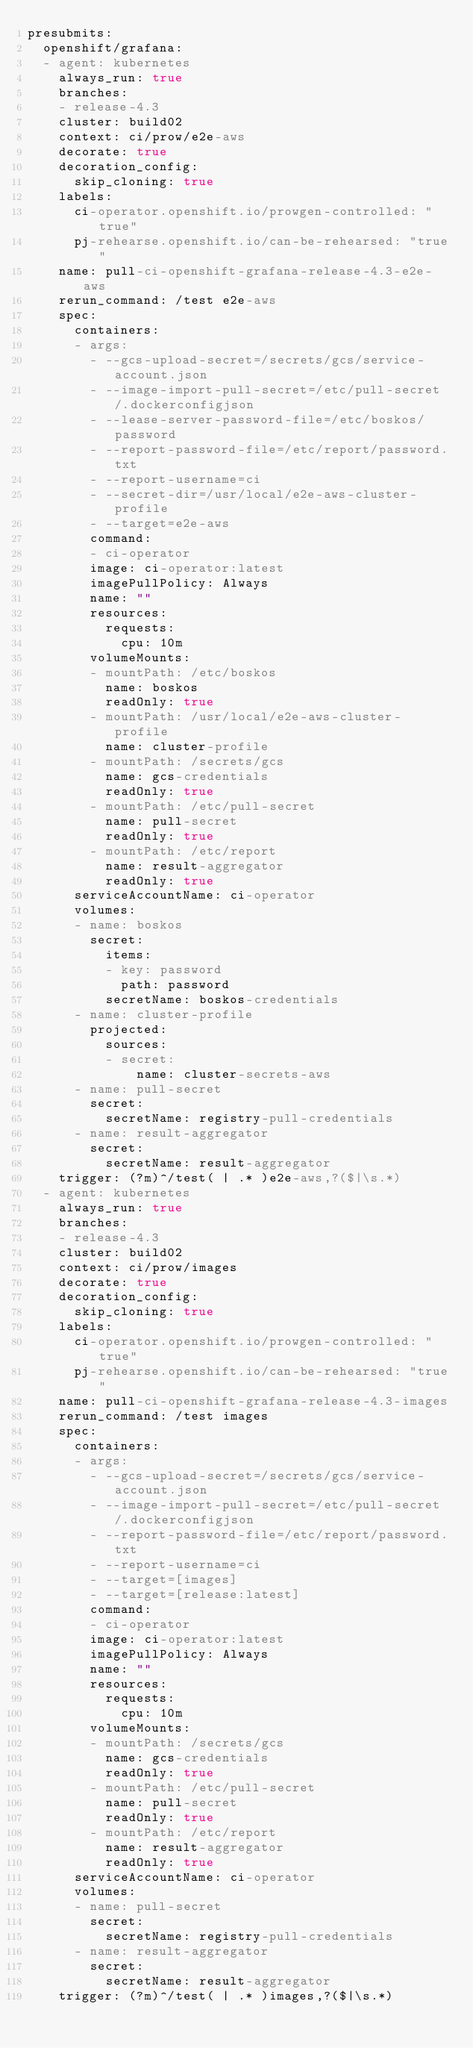<code> <loc_0><loc_0><loc_500><loc_500><_YAML_>presubmits:
  openshift/grafana:
  - agent: kubernetes
    always_run: true
    branches:
    - release-4.3
    cluster: build02
    context: ci/prow/e2e-aws
    decorate: true
    decoration_config:
      skip_cloning: true
    labels:
      ci-operator.openshift.io/prowgen-controlled: "true"
      pj-rehearse.openshift.io/can-be-rehearsed: "true"
    name: pull-ci-openshift-grafana-release-4.3-e2e-aws
    rerun_command: /test e2e-aws
    spec:
      containers:
      - args:
        - --gcs-upload-secret=/secrets/gcs/service-account.json
        - --image-import-pull-secret=/etc/pull-secret/.dockerconfigjson
        - --lease-server-password-file=/etc/boskos/password
        - --report-password-file=/etc/report/password.txt
        - --report-username=ci
        - --secret-dir=/usr/local/e2e-aws-cluster-profile
        - --target=e2e-aws
        command:
        - ci-operator
        image: ci-operator:latest
        imagePullPolicy: Always
        name: ""
        resources:
          requests:
            cpu: 10m
        volumeMounts:
        - mountPath: /etc/boskos
          name: boskos
          readOnly: true
        - mountPath: /usr/local/e2e-aws-cluster-profile
          name: cluster-profile
        - mountPath: /secrets/gcs
          name: gcs-credentials
          readOnly: true
        - mountPath: /etc/pull-secret
          name: pull-secret
          readOnly: true
        - mountPath: /etc/report
          name: result-aggregator
          readOnly: true
      serviceAccountName: ci-operator
      volumes:
      - name: boskos
        secret:
          items:
          - key: password
            path: password
          secretName: boskos-credentials
      - name: cluster-profile
        projected:
          sources:
          - secret:
              name: cluster-secrets-aws
      - name: pull-secret
        secret:
          secretName: registry-pull-credentials
      - name: result-aggregator
        secret:
          secretName: result-aggregator
    trigger: (?m)^/test( | .* )e2e-aws,?($|\s.*)
  - agent: kubernetes
    always_run: true
    branches:
    - release-4.3
    cluster: build02
    context: ci/prow/images
    decorate: true
    decoration_config:
      skip_cloning: true
    labels:
      ci-operator.openshift.io/prowgen-controlled: "true"
      pj-rehearse.openshift.io/can-be-rehearsed: "true"
    name: pull-ci-openshift-grafana-release-4.3-images
    rerun_command: /test images
    spec:
      containers:
      - args:
        - --gcs-upload-secret=/secrets/gcs/service-account.json
        - --image-import-pull-secret=/etc/pull-secret/.dockerconfigjson
        - --report-password-file=/etc/report/password.txt
        - --report-username=ci
        - --target=[images]
        - --target=[release:latest]
        command:
        - ci-operator
        image: ci-operator:latest
        imagePullPolicy: Always
        name: ""
        resources:
          requests:
            cpu: 10m
        volumeMounts:
        - mountPath: /secrets/gcs
          name: gcs-credentials
          readOnly: true
        - mountPath: /etc/pull-secret
          name: pull-secret
          readOnly: true
        - mountPath: /etc/report
          name: result-aggregator
          readOnly: true
      serviceAccountName: ci-operator
      volumes:
      - name: pull-secret
        secret:
          secretName: registry-pull-credentials
      - name: result-aggregator
        secret:
          secretName: result-aggregator
    trigger: (?m)^/test( | .* )images,?($|\s.*)
</code> 